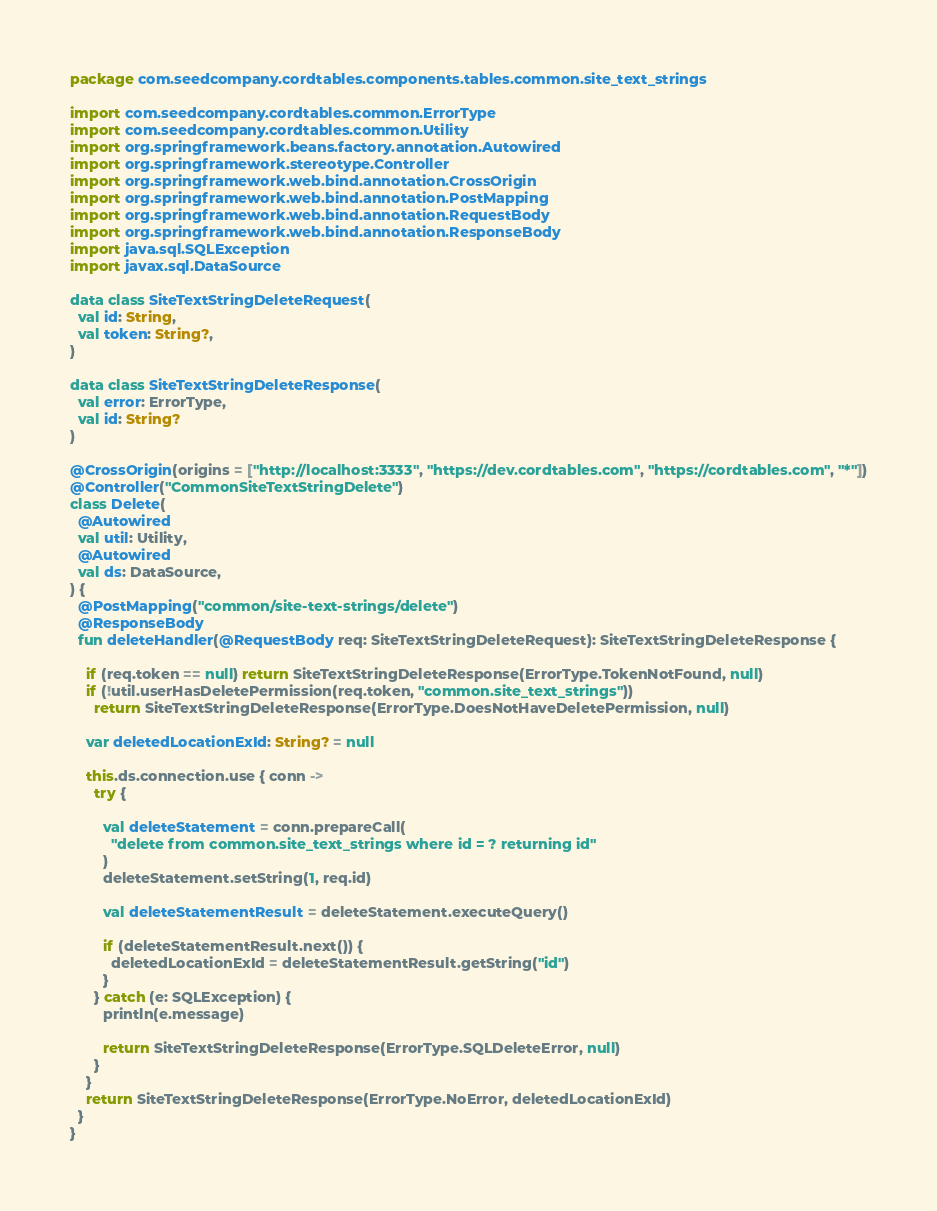Convert code to text. <code><loc_0><loc_0><loc_500><loc_500><_Kotlin_>package com.seedcompany.cordtables.components.tables.common.site_text_strings

import com.seedcompany.cordtables.common.ErrorType
import com.seedcompany.cordtables.common.Utility
import org.springframework.beans.factory.annotation.Autowired
import org.springframework.stereotype.Controller
import org.springframework.web.bind.annotation.CrossOrigin
import org.springframework.web.bind.annotation.PostMapping
import org.springframework.web.bind.annotation.RequestBody
import org.springframework.web.bind.annotation.ResponseBody
import java.sql.SQLException
import javax.sql.DataSource

data class SiteTextStringDeleteRequest(
  val id: String,
  val token: String?,
)

data class SiteTextStringDeleteResponse(
  val error: ErrorType,
  val id: String?
)

@CrossOrigin(origins = ["http://localhost:3333", "https://dev.cordtables.com", "https://cordtables.com", "*"])
@Controller("CommonSiteTextStringDelete")
class Delete(
  @Autowired
  val util: Utility,
  @Autowired
  val ds: DataSource,
) {
  @PostMapping("common/site-text-strings/delete")
  @ResponseBody
  fun deleteHandler(@RequestBody req: SiteTextStringDeleteRequest): SiteTextStringDeleteResponse {

    if (req.token == null) return SiteTextStringDeleteResponse(ErrorType.TokenNotFound, null)
    if (!util.userHasDeletePermission(req.token, "common.site_text_strings"))
      return SiteTextStringDeleteResponse(ErrorType.DoesNotHaveDeletePermission, null)

    var deletedLocationExId: String? = null

    this.ds.connection.use { conn ->
      try {

        val deleteStatement = conn.prepareCall(
          "delete from common.site_text_strings where id = ? returning id"
        )
        deleteStatement.setString(1, req.id)

        val deleteStatementResult = deleteStatement.executeQuery()

        if (deleteStatementResult.next()) {
          deletedLocationExId = deleteStatementResult.getString("id")
        }
      } catch (e: SQLException) {
        println(e.message)

        return SiteTextStringDeleteResponse(ErrorType.SQLDeleteError, null)
      }
    }
    return SiteTextStringDeleteResponse(ErrorType.NoError, deletedLocationExId)
  }
}
</code> 